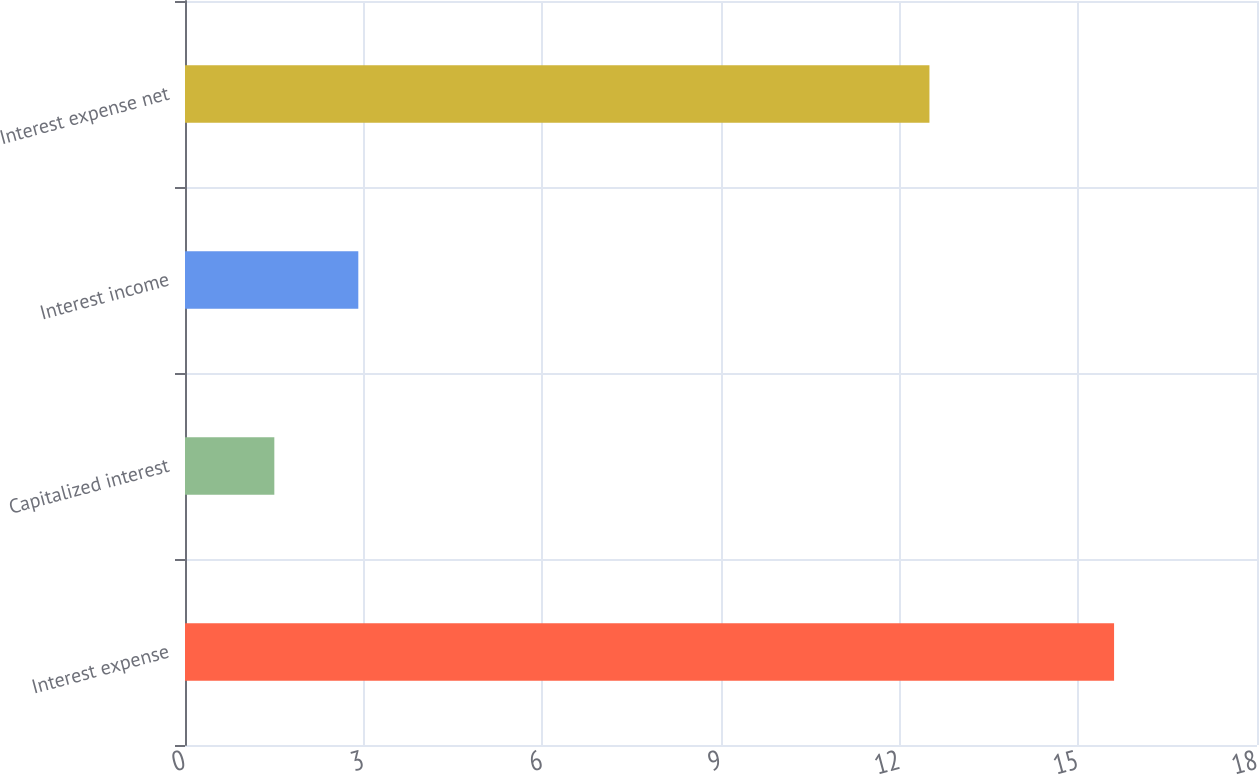Convert chart to OTSL. <chart><loc_0><loc_0><loc_500><loc_500><bar_chart><fcel>Interest expense<fcel>Capitalized interest<fcel>Interest income<fcel>Interest expense net<nl><fcel>15.6<fcel>1.5<fcel>2.91<fcel>12.5<nl></chart> 